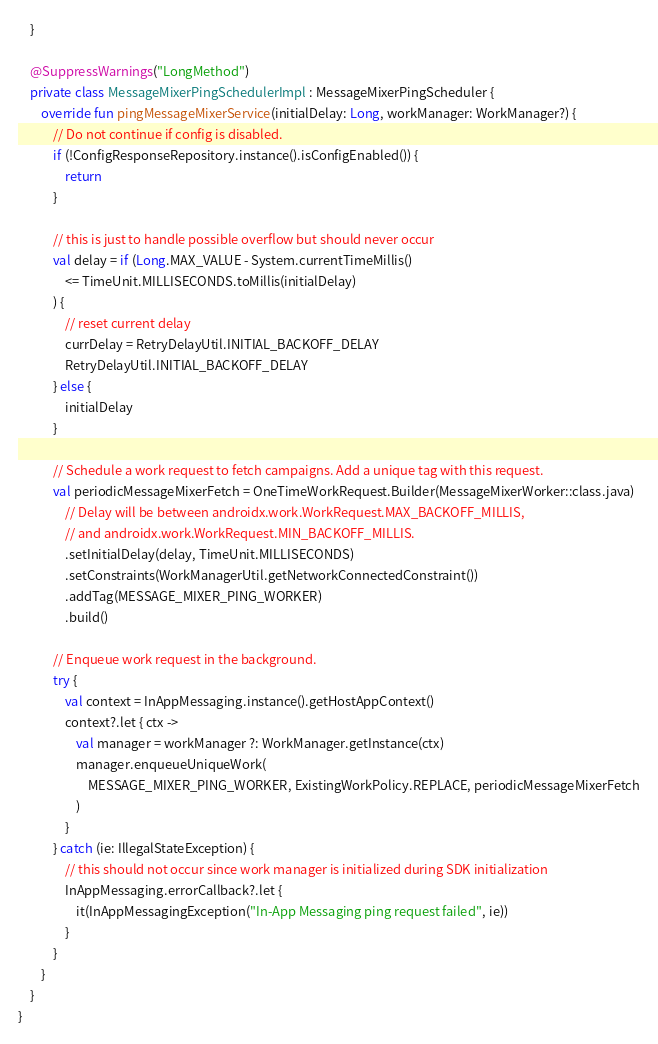Convert code to text. <code><loc_0><loc_0><loc_500><loc_500><_Kotlin_>    }

    @SuppressWarnings("LongMethod")
    private class MessageMixerPingSchedulerImpl : MessageMixerPingScheduler {
        override fun pingMessageMixerService(initialDelay: Long, workManager: WorkManager?) {
            // Do not continue if config is disabled.
            if (!ConfigResponseRepository.instance().isConfigEnabled()) {
                return
            }

            // this is just to handle possible overflow but should never occur
            val delay = if (Long.MAX_VALUE - System.currentTimeMillis()
                <= TimeUnit.MILLISECONDS.toMillis(initialDelay)
            ) {
                // reset current delay
                currDelay = RetryDelayUtil.INITIAL_BACKOFF_DELAY
                RetryDelayUtil.INITIAL_BACKOFF_DELAY
            } else {
                initialDelay
            }

            // Schedule a work request to fetch campaigns. Add a unique tag with this request.
            val periodicMessageMixerFetch = OneTimeWorkRequest.Builder(MessageMixerWorker::class.java)
                // Delay will be between androidx.work.WorkRequest.MAX_BACKOFF_MILLIS,
                // and androidx.work.WorkRequest.MIN_BACKOFF_MILLIS.
                .setInitialDelay(delay, TimeUnit.MILLISECONDS)
                .setConstraints(WorkManagerUtil.getNetworkConnectedConstraint())
                .addTag(MESSAGE_MIXER_PING_WORKER)
                .build()

            // Enqueue work request in the background.
            try {
                val context = InAppMessaging.instance().getHostAppContext()
                context?.let { ctx ->
                    val manager = workManager ?: WorkManager.getInstance(ctx)
                    manager.enqueueUniqueWork(
                        MESSAGE_MIXER_PING_WORKER, ExistingWorkPolicy.REPLACE, periodicMessageMixerFetch
                    )
                }
            } catch (ie: IllegalStateException) {
                // this should not occur since work manager is initialized during SDK initialization
                InAppMessaging.errorCallback?.let {
                    it(InAppMessagingException("In-App Messaging ping request failed", ie))
                }
            }
        }
    }
}
</code> 